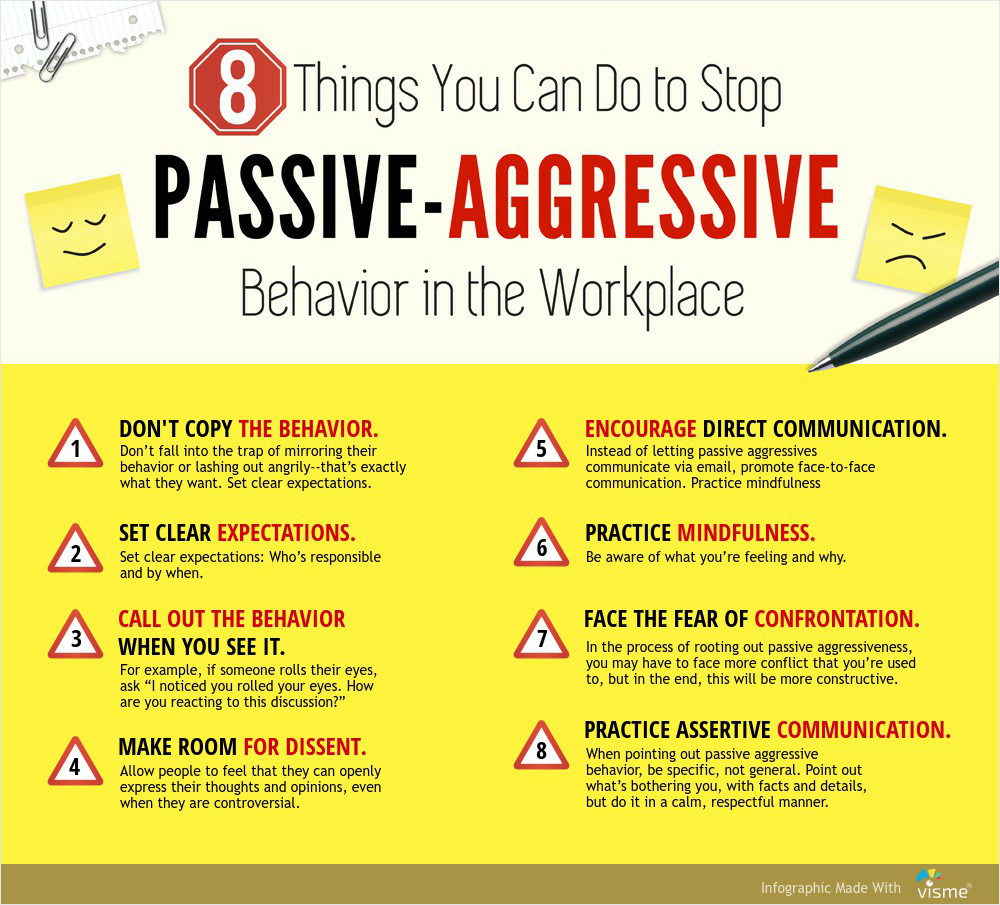What might be some realistic scenarios where these strategies can be applied effectively? A realistic scenario for Strategy 3, "CALL OUT THE BEHAVIOR WHEN YOU SEE IT": Imagine a team meeting where one team member, Alex, consistently rolls their eyes and sighs every time another team member, Casey, speaks. Using Strategy 3, the manager might address this by saying, "Alex, I noticed you rolled your eyes when Casey was speaking. Can we discuss any concerns you may have?" This approach directly calls out the passive-aggressive behavior and opens a dialogue for resolution.

A realistic scenario for Strategy 7, "FACE THE FEAR OF CONFRONTATION": Consider an employee, Jamie, who has been sending curt and dismissive emails to colleagues. When confronted about their behavior, Jamie might initially react defensively. By using Strategy 7, a manager could say, "Jamie, I've noticed that your emails have been rather terse lately, and it's affecting team morale. Let's talk about what's going on and how we can address it." This encourages Jamie to confront the underlying issues and work towards a more constructive communication style.  Are there any historical examples or famous personalities known for effectively dealing with passive-aggressive behavior? While it's difficult to pinpoint exact historical examples specifically focused on passive-aggressive behavior, many renowned leaders and personalities have demonstrated effective conflict resolution and communication skills, which can address such behavior. For instance, Mahatma Gandhi’s practice of nonviolent communication and assertiveness played a key role in addressing and resolving conflicts during the Indian independence movement. His approach emphasized direct, respectful communication and mindfulness, aligning with several strategies outlined in the infographic. Similarly, leaders like Nelson Mandela advocated for open dialogue and understanding, promoting a culture of direct and honest communication that can counteract passive-aggressive tendencies. 